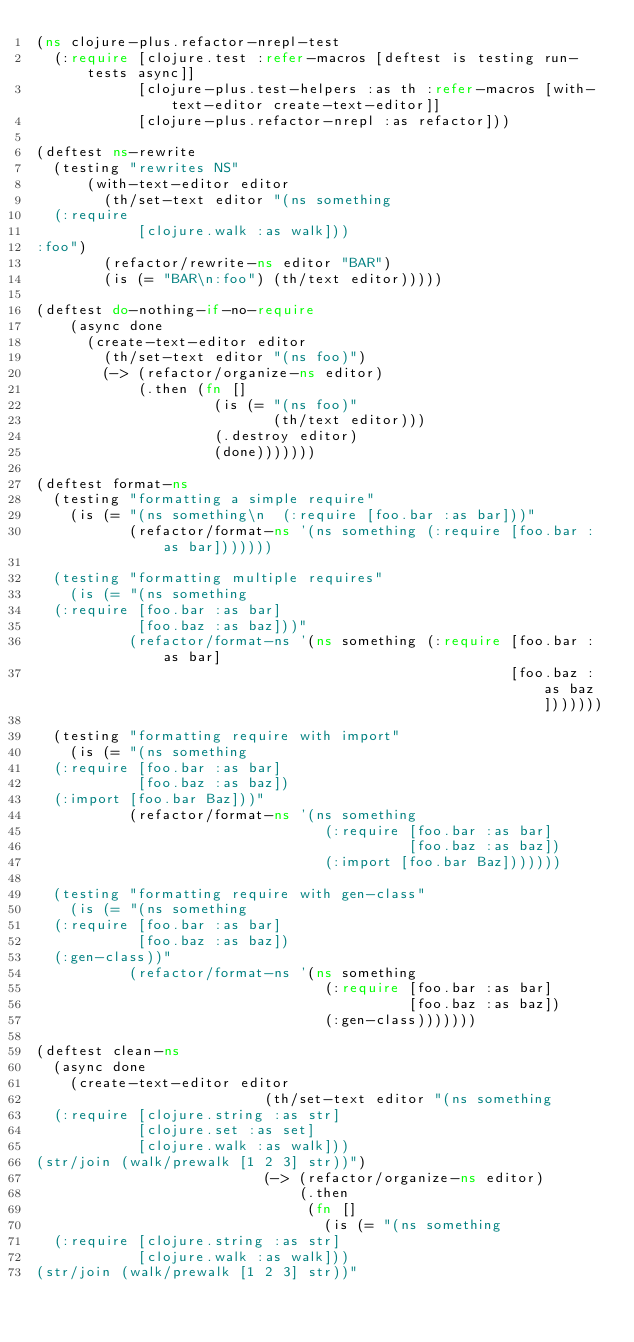Convert code to text. <code><loc_0><loc_0><loc_500><loc_500><_Clojure_>(ns clojure-plus.refactor-nrepl-test
  (:require [clojure.test :refer-macros [deftest is testing run-tests async]]
            [clojure-plus.test-helpers :as th :refer-macros [with-text-editor create-text-editor]]
            [clojure-plus.refactor-nrepl :as refactor]))

(deftest ns-rewrite
  (testing "rewrites NS"
      (with-text-editor editor
        (th/set-text editor "(ns something
  (:require
            [clojure.walk :as walk]))
:foo")
        (refactor/rewrite-ns editor "BAR")
        (is (= "BAR\n:foo") (th/text editor)))))

(deftest do-nothing-if-no-require
    (async done
      (create-text-editor editor
        (th/set-text editor "(ns foo)")
        (-> (refactor/organize-ns editor)
            (.then (fn []
                     (is (= "(ns foo)"
                            (th/text editor)))
                     (.destroy editor)
                     (done)))))))

(deftest format-ns
  (testing "formatting a simple require"
    (is (= "(ns something\n  (:require [foo.bar :as bar]))"
           (refactor/format-ns '(ns something (:require [foo.bar :as bar]))))))

  (testing "formatting multiple requires"
    (is (= "(ns something
  (:require [foo.bar :as bar]
            [foo.baz :as baz]))"
           (refactor/format-ns '(ns something (:require [foo.bar :as bar]
                                                        [foo.baz :as baz]))))))

  (testing "formatting require with import"
    (is (= "(ns something
  (:require [foo.bar :as bar]
            [foo.baz :as baz])
  (:import [foo.bar Baz]))"
           (refactor/format-ns '(ns something
                                  (:require [foo.bar :as bar]
                                            [foo.baz :as baz])
                                  (:import [foo.bar Baz]))))))

  (testing "formatting require with gen-class"
    (is (= "(ns something
  (:require [foo.bar :as bar]
            [foo.baz :as baz])
  (:gen-class))"
           (refactor/format-ns '(ns something
                                  (:require [foo.bar :as bar]
                                            [foo.baz :as baz])
                                  (:gen-class)))))))

(deftest clean-ns
  (async done
    (create-text-editor editor
                           (th/set-text editor "(ns something
  (:require [clojure.string :as str]
            [clojure.set :as set]
            [clojure.walk :as walk]))
(str/join (walk/prewalk [1 2 3] str))")
                           (-> (refactor/organize-ns editor)
                               (.then
                                (fn []
                                  (is (= "(ns something
  (:require [clojure.string :as str]
            [clojure.walk :as walk]))
(str/join (walk/prewalk [1 2 3] str))"</code> 